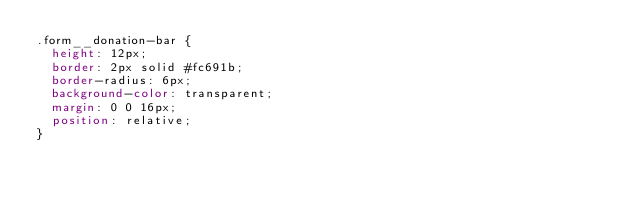<code> <loc_0><loc_0><loc_500><loc_500><_CSS_>.form__donation-bar {
  height: 12px;
  border: 2px solid #fc691b;
  border-radius: 6px;
  background-color: transparent;
  margin: 0 0 16px;
  position: relative;
}
</code> 